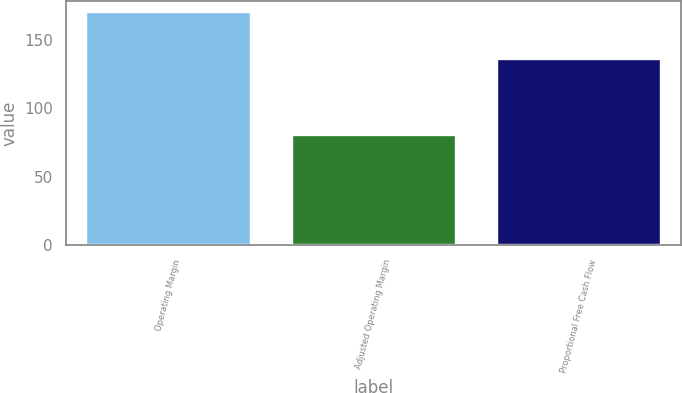Convert chart. <chart><loc_0><loc_0><loc_500><loc_500><bar_chart><fcel>Operating Margin<fcel>Adjusted Operating Margin<fcel>Proportional Free Cash Flow<nl><fcel>170<fcel>80<fcel>136<nl></chart> 